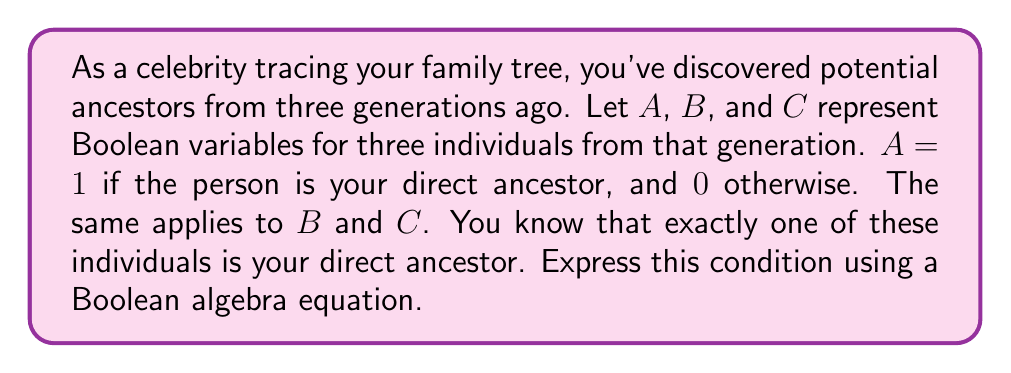What is the answer to this math problem? To solve this problem, we need to use Boolean algebra to express the condition that exactly one of $A$, $B$, or $C$ is true (1) while the others are false (0).

Step 1: Express each possible case:
- Case 1: $A$ is true, $B$ and $C$ are false: $A \cdot \overline{B} \cdot \overline{C}$
- Case 2: $B$ is true, $A$ and $C$ are false: $\overline{A} \cdot B \cdot \overline{C}$
- Case 3: $C$ is true, $A$ and $B$ are false: $\overline{A} \cdot \overline{B} \cdot C$

Step 2: Combine these cases using the OR operation (addition in Boolean algebra):
$$(A \cdot \overline{B} \cdot \overline{C}) + (\overline{A} \cdot B \cdot \overline{C}) + (\overline{A} \cdot \overline{B} \cdot C)$$

This equation represents the condition that exactly one of $A$, $B$, or $C$ is true.

Step 3: Simplify the equation (optional):
The equation in step 2 is already in its simplest form for this particular problem. It clearly shows that only one variable can be true at a time.
Answer: $(A \cdot \overline{B} \cdot \overline{C}) + (\overline{A} \cdot B \cdot \overline{C}) + (\overline{A} \cdot \overline{B} \cdot C)$ 